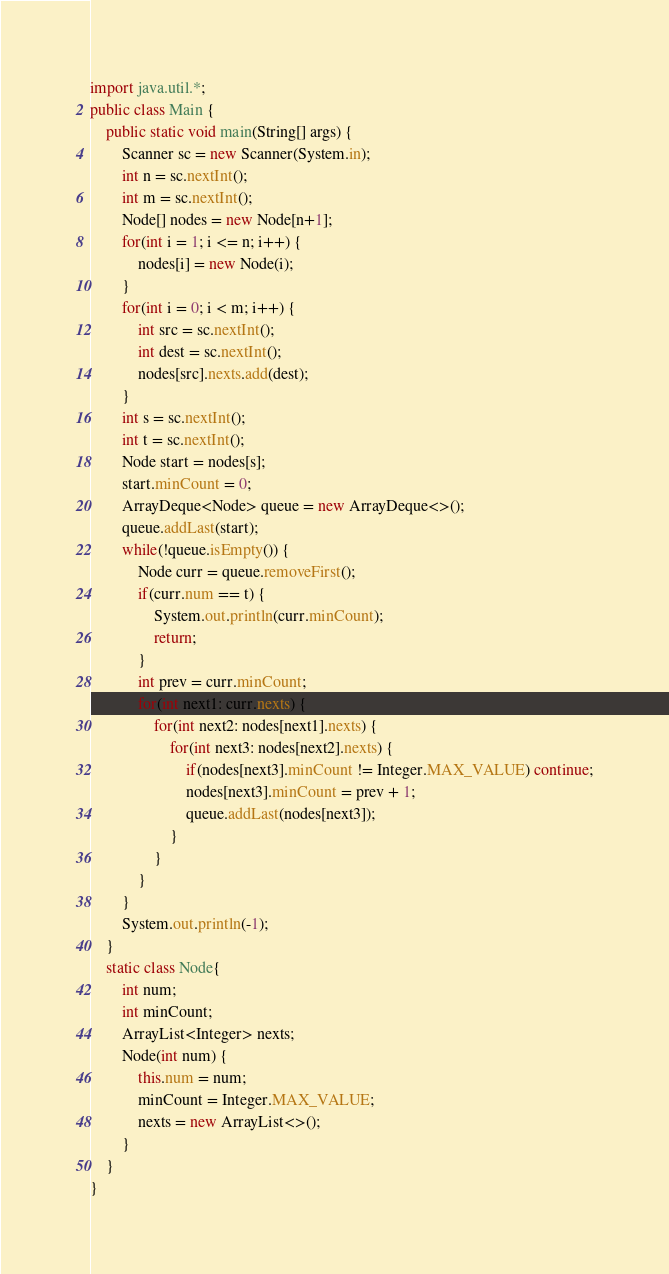Convert code to text. <code><loc_0><loc_0><loc_500><loc_500><_Java_>import java.util.*;
public class Main {
    public static void main(String[] args) {
        Scanner sc = new Scanner(System.in);
        int n = sc.nextInt();
        int m = sc.nextInt();
        Node[] nodes = new Node[n+1];
        for(int i = 1; i <= n; i++) {
            nodes[i] = new Node(i);
        }
        for(int i = 0; i < m; i++) {
            int src = sc.nextInt();
            int dest = sc.nextInt();
            nodes[src].nexts.add(dest);
        }
        int s = sc.nextInt();
        int t = sc.nextInt();
        Node start = nodes[s];
        start.minCount = 0;
        ArrayDeque<Node> queue = new ArrayDeque<>();
        queue.addLast(start);
        while(!queue.isEmpty()) {
            Node curr = queue.removeFirst();
            if(curr.num == t) {
                System.out.println(curr.minCount);
                return;
            }
            int prev = curr.minCount;
            for(int next1: curr.nexts) {
                for(int next2: nodes[next1].nexts) {
                    for(int next3: nodes[next2].nexts) {
                        if(nodes[next3].minCount != Integer.MAX_VALUE) continue;
                        nodes[next3].minCount = prev + 1;
                        queue.addLast(nodes[next3]);
                    }
                }
            }
        }
        System.out.println(-1);
    }
    static class Node{
        int num;
        int minCount;
        ArrayList<Integer> nexts;
        Node(int num) {
            this.num = num;
            minCount = Integer.MAX_VALUE;
            nexts = new ArrayList<>();
        }
    }
}</code> 